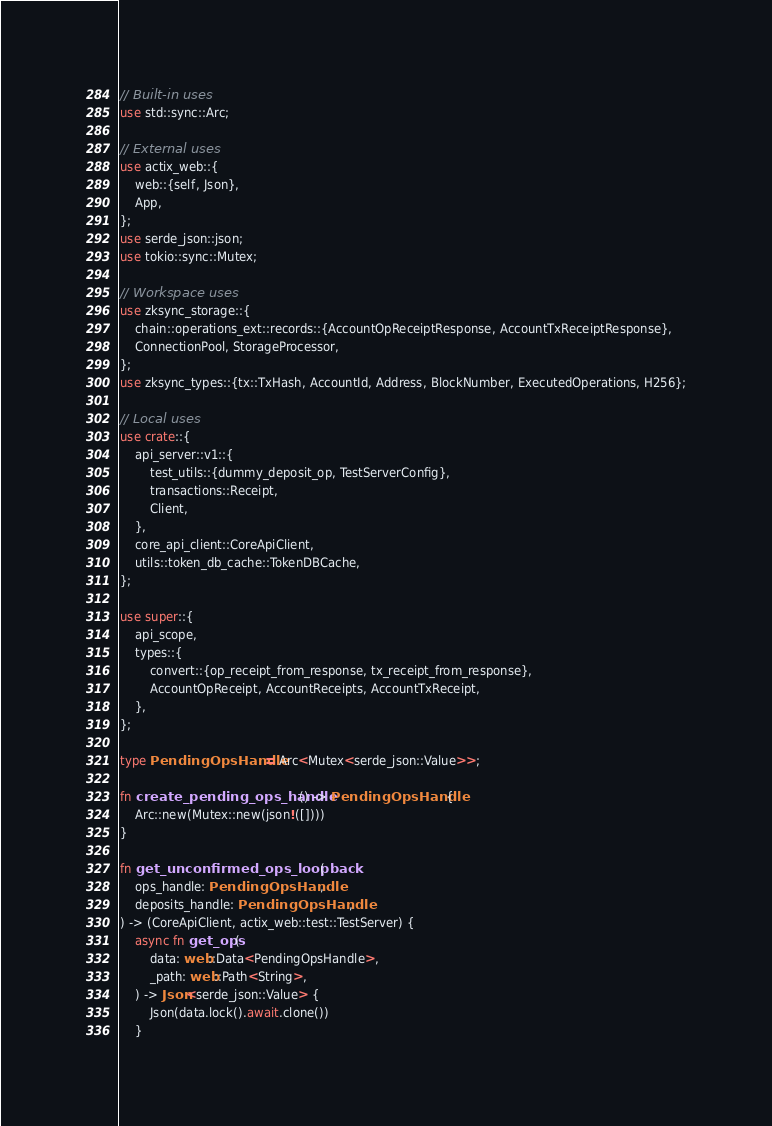<code> <loc_0><loc_0><loc_500><loc_500><_Rust_>// Built-in uses
use std::sync::Arc;

// External uses
use actix_web::{
    web::{self, Json},
    App,
};
use serde_json::json;
use tokio::sync::Mutex;

// Workspace uses
use zksync_storage::{
    chain::operations_ext::records::{AccountOpReceiptResponse, AccountTxReceiptResponse},
    ConnectionPool, StorageProcessor,
};
use zksync_types::{tx::TxHash, AccountId, Address, BlockNumber, ExecutedOperations, H256};

// Local uses
use crate::{
    api_server::v1::{
        test_utils::{dummy_deposit_op, TestServerConfig},
        transactions::Receipt,
        Client,
    },
    core_api_client::CoreApiClient,
    utils::token_db_cache::TokenDBCache,
};

use super::{
    api_scope,
    types::{
        convert::{op_receipt_from_response, tx_receipt_from_response},
        AccountOpReceipt, AccountReceipts, AccountTxReceipt,
    },
};

type PendingOpsHandle = Arc<Mutex<serde_json::Value>>;

fn create_pending_ops_handle() -> PendingOpsHandle {
    Arc::new(Mutex::new(json!([])))
}

fn get_unconfirmed_ops_loopback(
    ops_handle: PendingOpsHandle,
    deposits_handle: PendingOpsHandle,
) -> (CoreApiClient, actix_web::test::TestServer) {
    async fn get_ops(
        data: web::Data<PendingOpsHandle>,
        _path: web::Path<String>,
    ) -> Json<serde_json::Value> {
        Json(data.lock().await.clone())
    }
</code> 